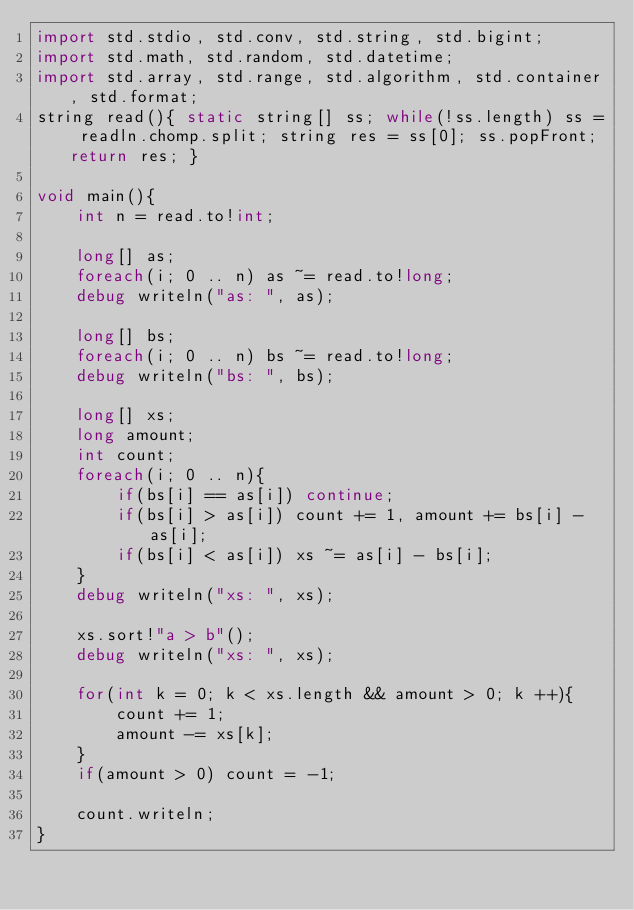<code> <loc_0><loc_0><loc_500><loc_500><_D_>import std.stdio, std.conv, std.string, std.bigint;
import std.math, std.random, std.datetime;
import std.array, std.range, std.algorithm, std.container, std.format;
string read(){ static string[] ss; while(!ss.length) ss = readln.chomp.split; string res = ss[0]; ss.popFront; return res; }

void main(){
	int n = read.to!int;
	
	long[] as;
	foreach(i; 0 .. n) as ~= read.to!long;
	debug writeln("as: ", as);
	
	long[] bs;
	foreach(i; 0 .. n) bs ~= read.to!long;
	debug writeln("bs: ", bs);
	
	long[] xs;
	long amount;
	int count;
	foreach(i; 0 .. n){
		if(bs[i] == as[i]) continue;
		if(bs[i] > as[i]) count += 1, amount += bs[i] - as[i];
		if(bs[i] < as[i]) xs ~= as[i] - bs[i];
	}
	debug writeln("xs: ", xs);
	
	xs.sort!"a > b"();
	debug writeln("xs: ", xs);
	
	for(int k = 0; k < xs.length && amount > 0; k ++){
		count += 1;
		amount -= xs[k];
	}
	if(amount > 0) count = -1;
	
	count.writeln;
}
</code> 